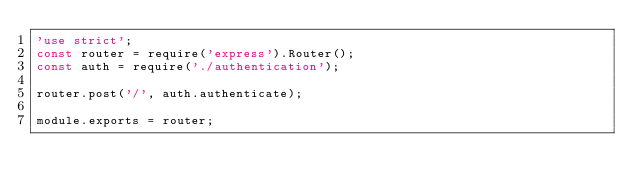<code> <loc_0><loc_0><loc_500><loc_500><_JavaScript_>'use strict';
const router = require('express').Router();
const auth = require('./authentication');

router.post('/', auth.authenticate);

module.exports = router;
</code> 